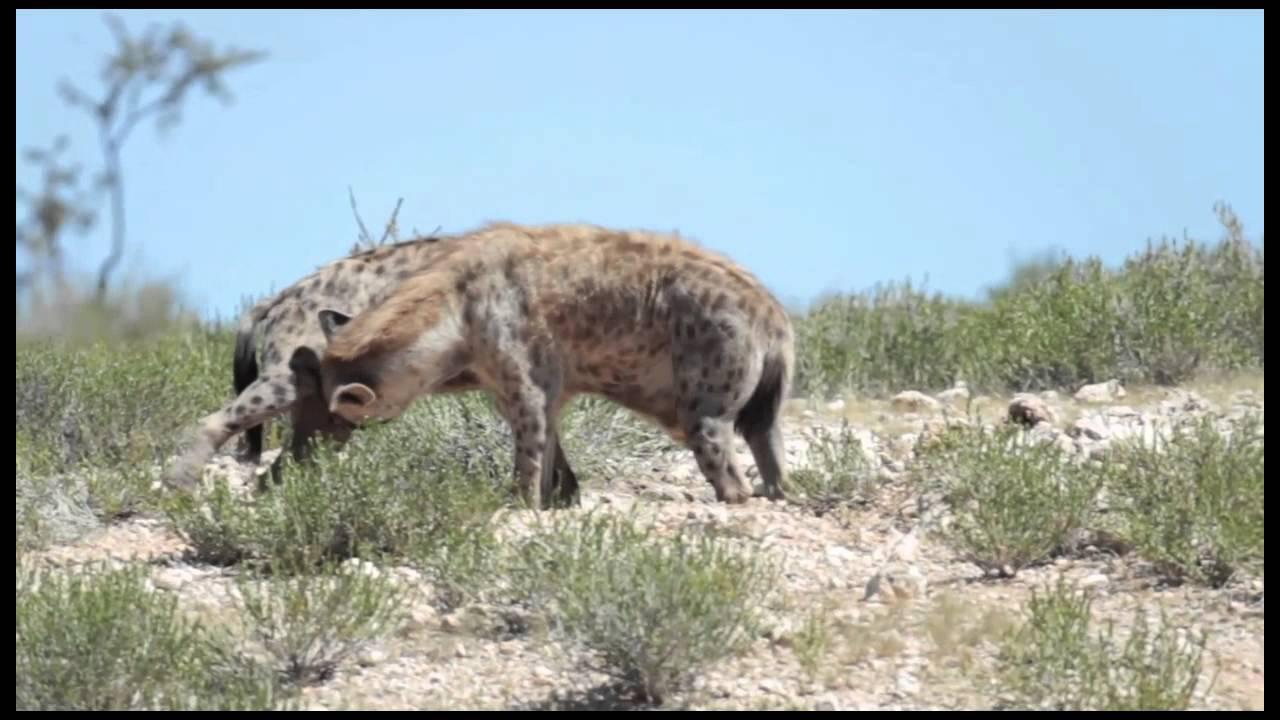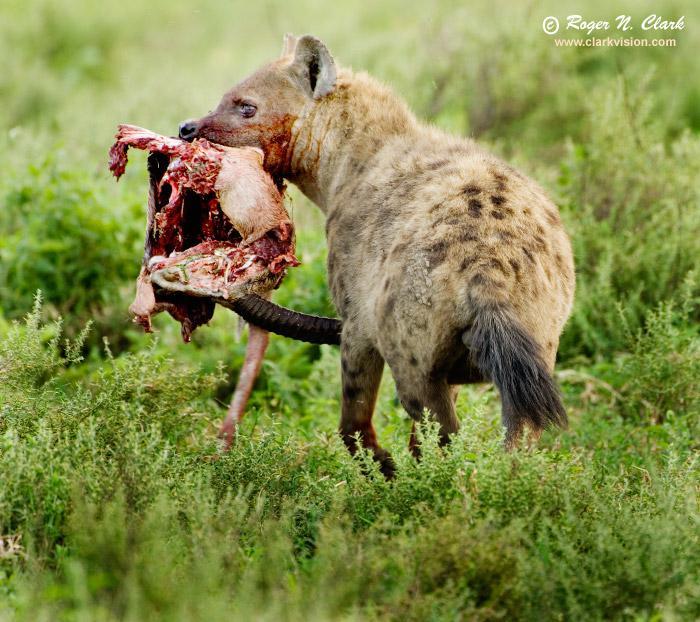The first image is the image on the left, the second image is the image on the right. Analyze the images presented: Is the assertion "One image contains at least four hyenas." valid? Answer yes or no. No. The first image is the image on the left, the second image is the image on the right. Assess this claim about the two images: "There are at least three spotted hyenas gathered together in the right image.". Correct or not? Answer yes or no. No. 